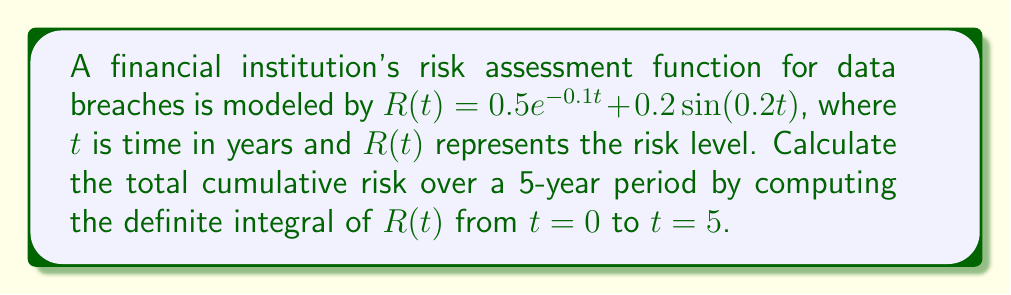Can you solve this math problem? To solve this problem, we need to integrate the risk assessment function $R(t)$ over the given time interval. Let's break it down step-by-step:

1) The integral we need to calculate is:

   $$\int_0^5 R(t) dt = \int_0^5 (0.5e^{-0.1t} + 0.2\sin(0.2t)) dt$$

2) We can split this into two integrals:

   $$\int_0^5 0.5e^{-0.1t} dt + \int_0^5 0.2\sin(0.2t) dt$$

3) For the first integral:
   
   $$\int 0.5e^{-0.1t} dt = -5e^{-0.1t} + C$$
   
   Evaluating from 0 to 5:
   
   $$[-5e^{-0.1t}]_0^5 = -5e^{-0.5} - (-5) = 5 - 5e^{-0.5}$$

4) For the second integral:
   
   $$\int 0.2\sin(0.2t) dt = -\cos(0.2t) + C$$
   
   Evaluating from 0 to 5:
   
   $$[-\cos(0.2t)]_0^5 = -\cos(1) - (-1) = 1 - \cos(1)$$

5) Adding the results from steps 3 and 4:

   $$\int_0^5 R(t) dt = (5 - 5e^{-0.5}) + (1 - \cos(1))$$

6) Simplifying:

   $$\int_0^5 R(t) dt = 6 - 5e^{-0.5} - \cos(1)$$

This result represents the total cumulative risk over the 5-year period.
Answer: $6 - 5e^{-0.5} - \cos(1) \approx 3.4372$ 